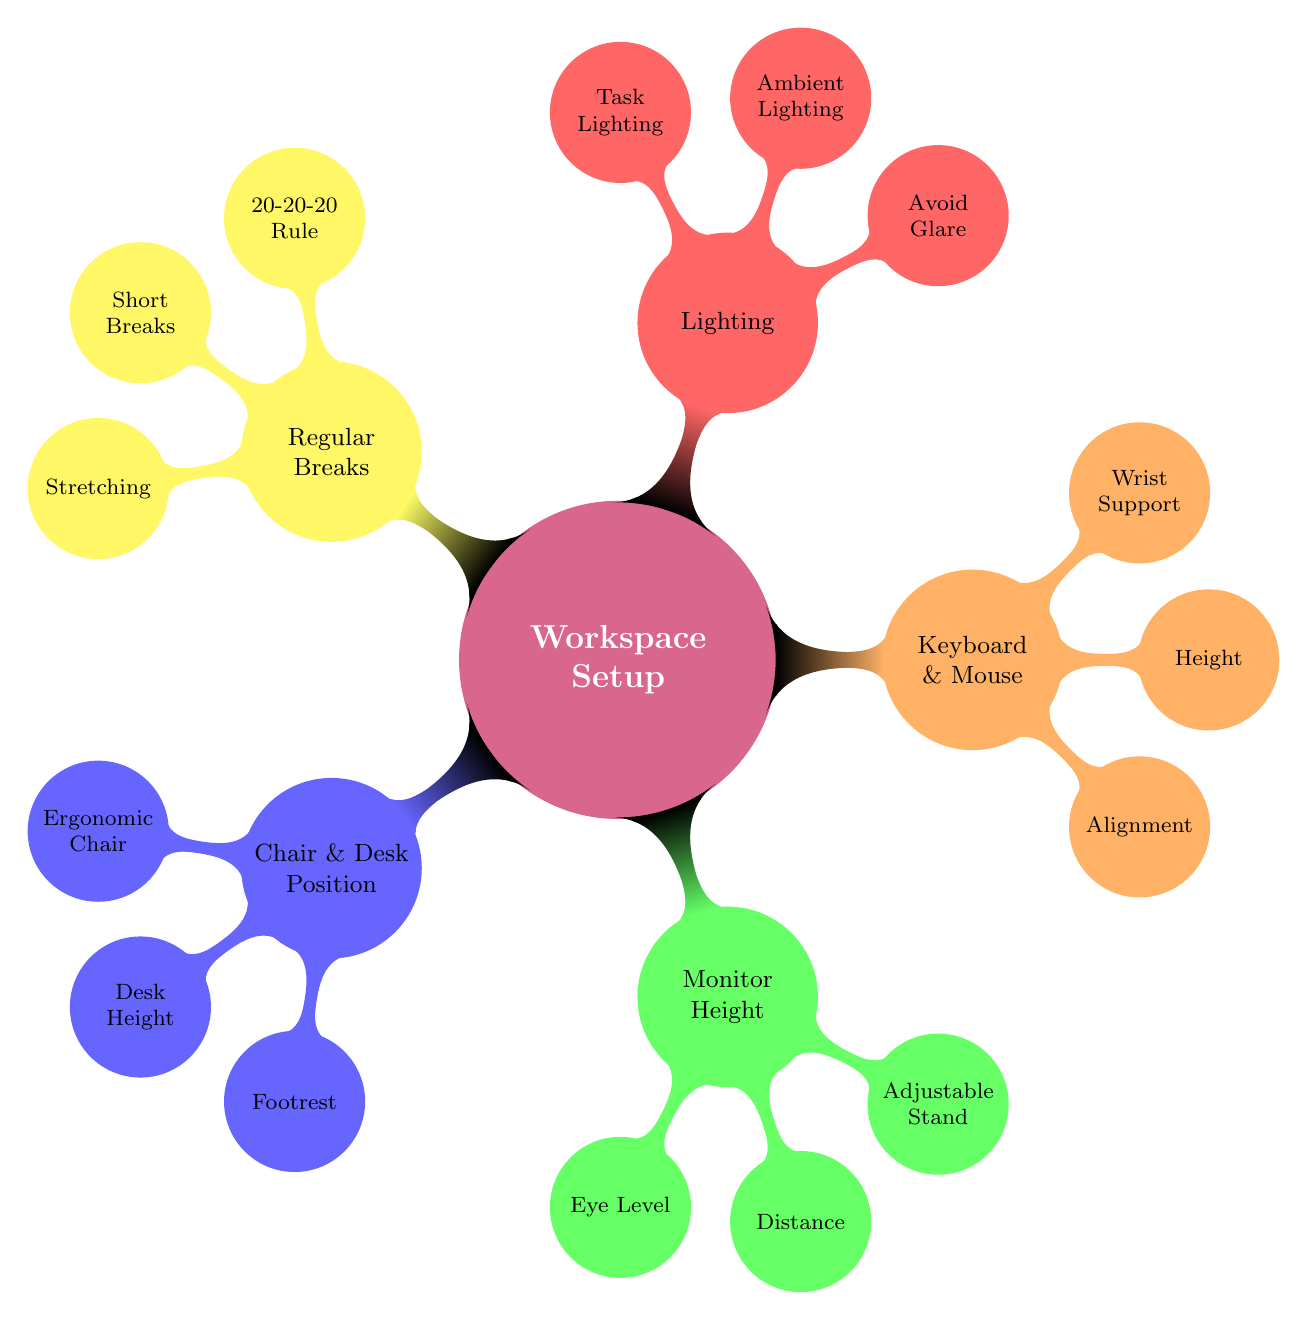What's the main node of the diagram? The main node is labeled "Workspace Setup," representing the central theme of the mind map.
Answer: Workspace Setup How many branches are connected to the main node? The main node has five branches connected to it, each representing different aspects of workspace setup.
Answer: 5 What is one feature of an ergonomic chair listed in the diagram? The diagram mentions "Adjustable seat height" as one feature of an ergonomic chair.
Answer: Adjustable seat height What is the recommended eye level for the monitor? The guideline states that the "Top of monitor at or slightly below eye level," indicating where the monitor should be positioned.
Answer: Top of monitor at or slightly below eye level What is the purpose of the 20-20-20 rule? The 20-20-20 rule is intended to help prevent eye strain by encouraging breaks every 20 minutes.
Answer: Help prevent eye strain What is the relationship between the "Keyboard Position" and "Mouse Position"? The diagram indicates that the "Keyboard centered with monitor" directly relates to the "mouse close to keyboard," highlighting their alignment importance.
Answer: Keyboard centered with monitor, mouse close to keyboard What should the ambient lighting in a workspace be like? The ambient lighting should be "Soft, even lighting in the room," ensuring a comfortable workspace environment.
Answer: Soft, even lighting in the room What type of support can a footrest provide? The diagram lists the footrest as an "Optional" addition for "additional comfort and support."
Answer: Additional comfort and support Why is wrist support important according to the diagram? The diagram suggests that a "Soft padding" helps to "reduce strain," indicating the significance of wrist support in ergonomics.
Answer: Reduce strain What does "Avoid Glare" suggest about lighting in the workspace? "Avoid Glare" implies that the workspace should be shielded from direct light to create a comfortable viewing environment for the screen.
Answer: Shielded from direct light 